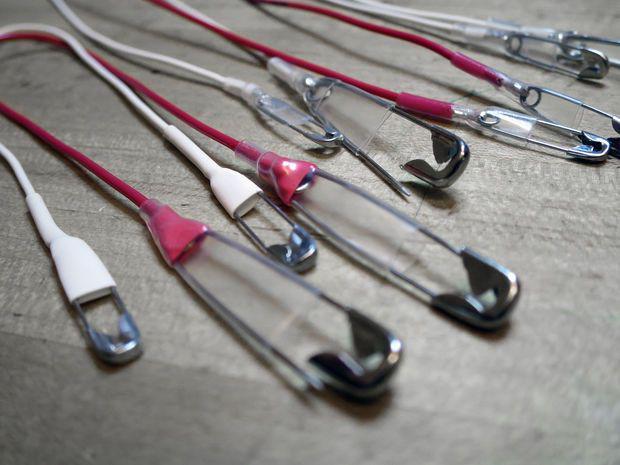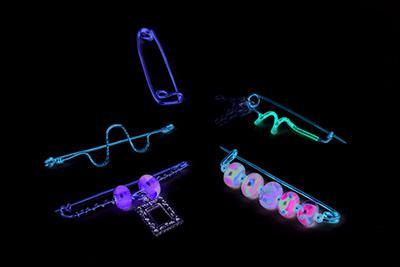The first image is the image on the left, the second image is the image on the right. Assess this claim about the two images: "One safety pin is open and one is closed.". Correct or not? Answer yes or no. No. The first image is the image on the left, the second image is the image on the right. Given the left and right images, does the statement "There are two safety pins" hold true? Answer yes or no. No. 